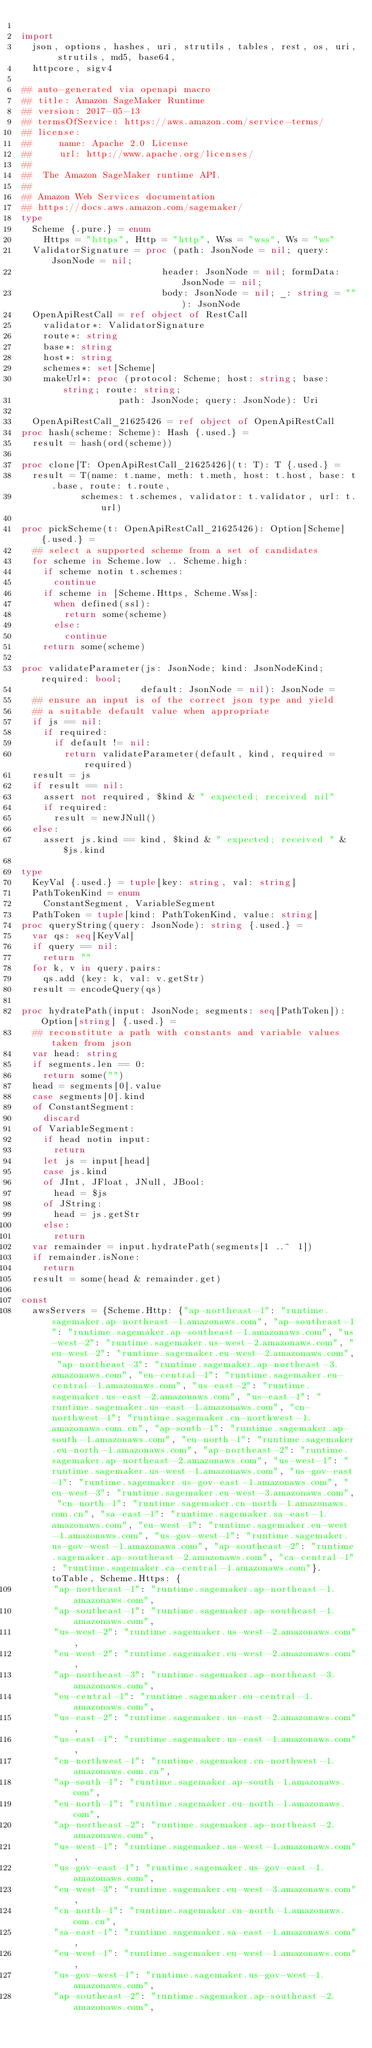Convert code to text. <code><loc_0><loc_0><loc_500><loc_500><_Nim_>
import
  json, options, hashes, uri, strutils, tables, rest, os, uri, strutils, md5, base64,
  httpcore, sigv4

## auto-generated via openapi macro
## title: Amazon SageMaker Runtime
## version: 2017-05-13
## termsOfService: https://aws.amazon.com/service-terms/
## license:
##     name: Apache 2.0 License
##     url: http://www.apache.org/licenses/
## 
##  The Amazon SageMaker runtime API. 
## 
## Amazon Web Services documentation
## https://docs.aws.amazon.com/sagemaker/
type
  Scheme {.pure.} = enum
    Https = "https", Http = "http", Wss = "wss", Ws = "ws"
  ValidatorSignature = proc (path: JsonNode = nil; query: JsonNode = nil;
                          header: JsonNode = nil; formData: JsonNode = nil;
                          body: JsonNode = nil; _: string = ""): JsonNode
  OpenApiRestCall = ref object of RestCall
    validator*: ValidatorSignature
    route*: string
    base*: string
    host*: string
    schemes*: set[Scheme]
    makeUrl*: proc (protocol: Scheme; host: string; base: string; route: string;
                  path: JsonNode; query: JsonNode): Uri

  OpenApiRestCall_21625426 = ref object of OpenApiRestCall
proc hash(scheme: Scheme): Hash {.used.} =
  result = hash(ord(scheme))

proc clone[T: OpenApiRestCall_21625426](t: T): T {.used.} =
  result = T(name: t.name, meth: t.meth, host: t.host, base: t.base, route: t.route,
           schemes: t.schemes, validator: t.validator, url: t.url)

proc pickScheme(t: OpenApiRestCall_21625426): Option[Scheme] {.used.} =
  ## select a supported scheme from a set of candidates
  for scheme in Scheme.low .. Scheme.high:
    if scheme notin t.schemes:
      continue
    if scheme in [Scheme.Https, Scheme.Wss]:
      when defined(ssl):
        return some(scheme)
      else:
        continue
    return some(scheme)

proc validateParameter(js: JsonNode; kind: JsonNodeKind; required: bool;
                      default: JsonNode = nil): JsonNode =
  ## ensure an input is of the correct json type and yield
  ## a suitable default value when appropriate
  if js == nil:
    if required:
      if default != nil:
        return validateParameter(default, kind, required = required)
  result = js
  if result == nil:
    assert not required, $kind & " expected; received nil"
    if required:
      result = newJNull()
  else:
    assert js.kind == kind, $kind & " expected; received " & $js.kind

type
  KeyVal {.used.} = tuple[key: string, val: string]
  PathTokenKind = enum
    ConstantSegment, VariableSegment
  PathToken = tuple[kind: PathTokenKind, value: string]
proc queryString(query: JsonNode): string {.used.} =
  var qs: seq[KeyVal]
  if query == nil:
    return ""
  for k, v in query.pairs:
    qs.add (key: k, val: v.getStr)
  result = encodeQuery(qs)

proc hydratePath(input: JsonNode; segments: seq[PathToken]): Option[string] {.used.} =
  ## reconstitute a path with constants and variable values taken from json
  var head: string
  if segments.len == 0:
    return some("")
  head = segments[0].value
  case segments[0].kind
  of ConstantSegment:
    discard
  of VariableSegment:
    if head notin input:
      return
    let js = input[head]
    case js.kind
    of JInt, JFloat, JNull, JBool:
      head = $js
    of JString:
      head = js.getStr
    else:
      return
  var remainder = input.hydratePath(segments[1 ..^ 1])
  if remainder.isNone:
    return
  result = some(head & remainder.get)

const
  awsServers = {Scheme.Http: {"ap-northeast-1": "runtime.sagemaker.ap-northeast-1.amazonaws.com", "ap-southeast-1": "runtime.sagemaker.ap-southeast-1.amazonaws.com", "us-west-2": "runtime.sagemaker.us-west-2.amazonaws.com", "eu-west-2": "runtime.sagemaker.eu-west-2.amazonaws.com", "ap-northeast-3": "runtime.sagemaker.ap-northeast-3.amazonaws.com", "eu-central-1": "runtime.sagemaker.eu-central-1.amazonaws.com", "us-east-2": "runtime.sagemaker.us-east-2.amazonaws.com", "us-east-1": "runtime.sagemaker.us-east-1.amazonaws.com", "cn-northwest-1": "runtime.sagemaker.cn-northwest-1.amazonaws.com.cn", "ap-south-1": "runtime.sagemaker.ap-south-1.amazonaws.com", "eu-north-1": "runtime.sagemaker.eu-north-1.amazonaws.com", "ap-northeast-2": "runtime.sagemaker.ap-northeast-2.amazonaws.com", "us-west-1": "runtime.sagemaker.us-west-1.amazonaws.com", "us-gov-east-1": "runtime.sagemaker.us-gov-east-1.amazonaws.com", "eu-west-3": "runtime.sagemaker.eu-west-3.amazonaws.com", "cn-north-1": "runtime.sagemaker.cn-north-1.amazonaws.com.cn", "sa-east-1": "runtime.sagemaker.sa-east-1.amazonaws.com", "eu-west-1": "runtime.sagemaker.eu-west-1.amazonaws.com", "us-gov-west-1": "runtime.sagemaker.us-gov-west-1.amazonaws.com", "ap-southeast-2": "runtime.sagemaker.ap-southeast-2.amazonaws.com", "ca-central-1": "runtime.sagemaker.ca-central-1.amazonaws.com"}.toTable, Scheme.Https: {
      "ap-northeast-1": "runtime.sagemaker.ap-northeast-1.amazonaws.com",
      "ap-southeast-1": "runtime.sagemaker.ap-southeast-1.amazonaws.com",
      "us-west-2": "runtime.sagemaker.us-west-2.amazonaws.com",
      "eu-west-2": "runtime.sagemaker.eu-west-2.amazonaws.com",
      "ap-northeast-3": "runtime.sagemaker.ap-northeast-3.amazonaws.com",
      "eu-central-1": "runtime.sagemaker.eu-central-1.amazonaws.com",
      "us-east-2": "runtime.sagemaker.us-east-2.amazonaws.com",
      "us-east-1": "runtime.sagemaker.us-east-1.amazonaws.com",
      "cn-northwest-1": "runtime.sagemaker.cn-northwest-1.amazonaws.com.cn",
      "ap-south-1": "runtime.sagemaker.ap-south-1.amazonaws.com",
      "eu-north-1": "runtime.sagemaker.eu-north-1.amazonaws.com",
      "ap-northeast-2": "runtime.sagemaker.ap-northeast-2.amazonaws.com",
      "us-west-1": "runtime.sagemaker.us-west-1.amazonaws.com",
      "us-gov-east-1": "runtime.sagemaker.us-gov-east-1.amazonaws.com",
      "eu-west-3": "runtime.sagemaker.eu-west-3.amazonaws.com",
      "cn-north-1": "runtime.sagemaker.cn-north-1.amazonaws.com.cn",
      "sa-east-1": "runtime.sagemaker.sa-east-1.amazonaws.com",
      "eu-west-1": "runtime.sagemaker.eu-west-1.amazonaws.com",
      "us-gov-west-1": "runtime.sagemaker.us-gov-west-1.amazonaws.com",
      "ap-southeast-2": "runtime.sagemaker.ap-southeast-2.amazonaws.com",</code> 